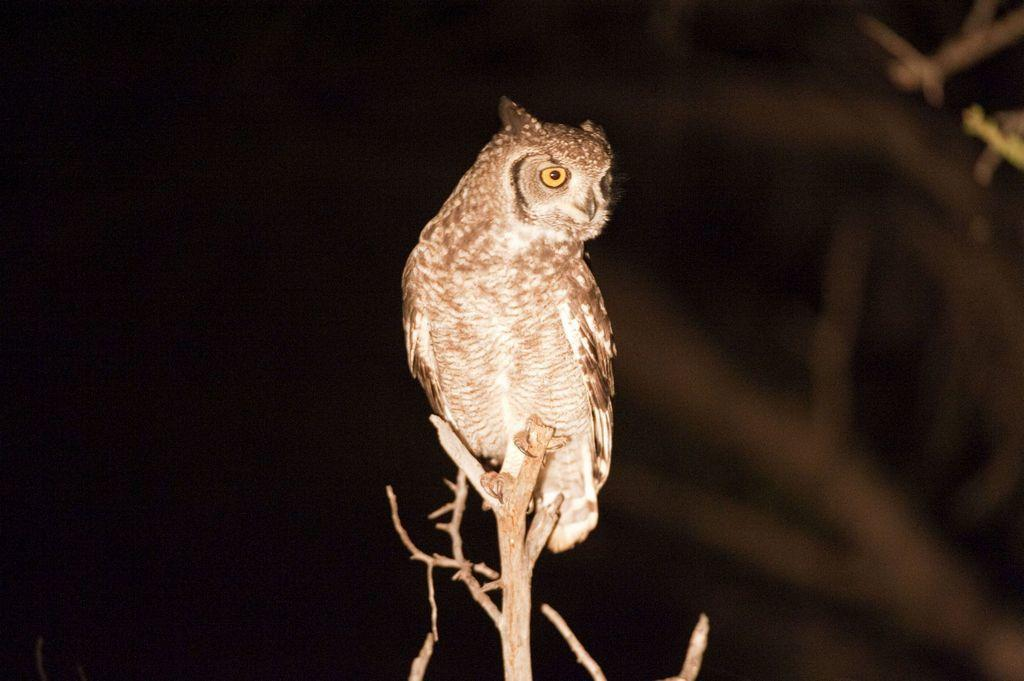What animal is featured in the picture? There is an owl in the picture. What color is the owl? The owl is brown in color. What can be observed about the background of the image? The background of the image is dark. What part of the owl is causing trouble in the image? There is no indication in the image that any part of the owl is causing trouble. 